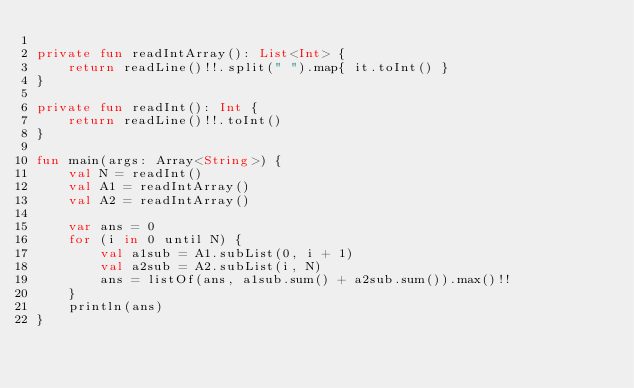<code> <loc_0><loc_0><loc_500><loc_500><_Kotlin_>
private fun readIntArray(): List<Int> {
    return readLine()!!.split(" ").map{ it.toInt() }
}

private fun readInt(): Int {
    return readLine()!!.toInt()
}

fun main(args: Array<String>) {
    val N = readInt()
    val A1 = readIntArray()
    val A2 = readIntArray()

    var ans = 0
    for (i in 0 until N) {
        val a1sub = A1.subList(0, i + 1)
        val a2sub = A2.subList(i, N)
        ans = listOf(ans, a1sub.sum() + a2sub.sum()).max()!!
    }
    println(ans)
}
</code> 